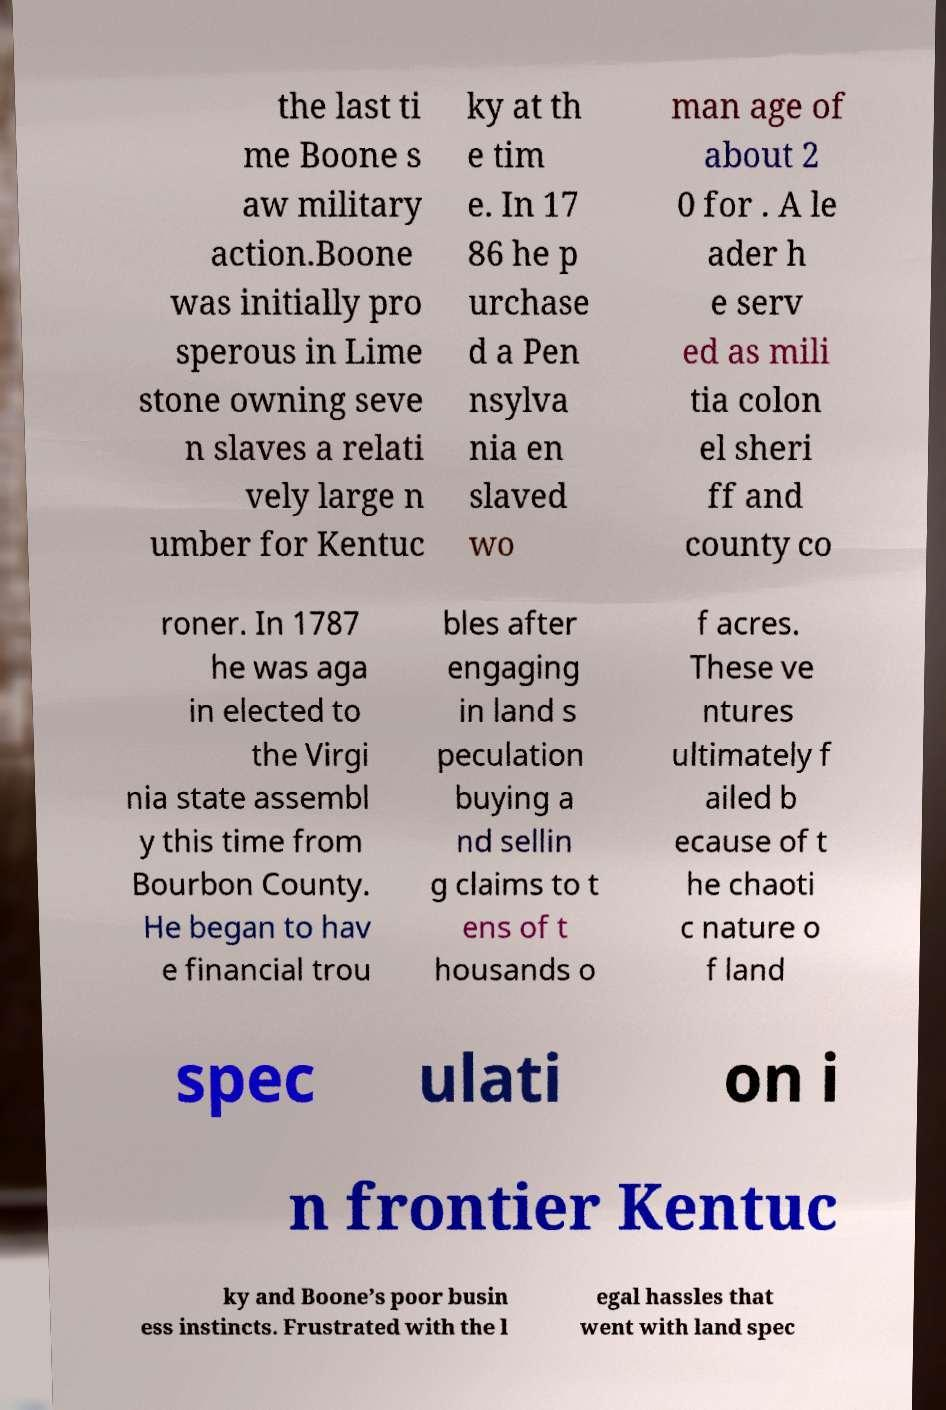Can you read and provide the text displayed in the image?This photo seems to have some interesting text. Can you extract and type it out for me? the last ti me Boone s aw military action.Boone was initially pro sperous in Lime stone owning seve n slaves a relati vely large n umber for Kentuc ky at th e tim e. In 17 86 he p urchase d a Pen nsylva nia en slaved wo man age of about 2 0 for . A le ader h e serv ed as mili tia colon el sheri ff and county co roner. In 1787 he was aga in elected to the Virgi nia state assembl y this time from Bourbon County. He began to hav e financial trou bles after engaging in land s peculation buying a nd sellin g claims to t ens of t housands o f acres. These ve ntures ultimately f ailed b ecause of t he chaoti c nature o f land spec ulati on i n frontier Kentuc ky and Boone’s poor busin ess instincts. Frustrated with the l egal hassles that went with land spec 